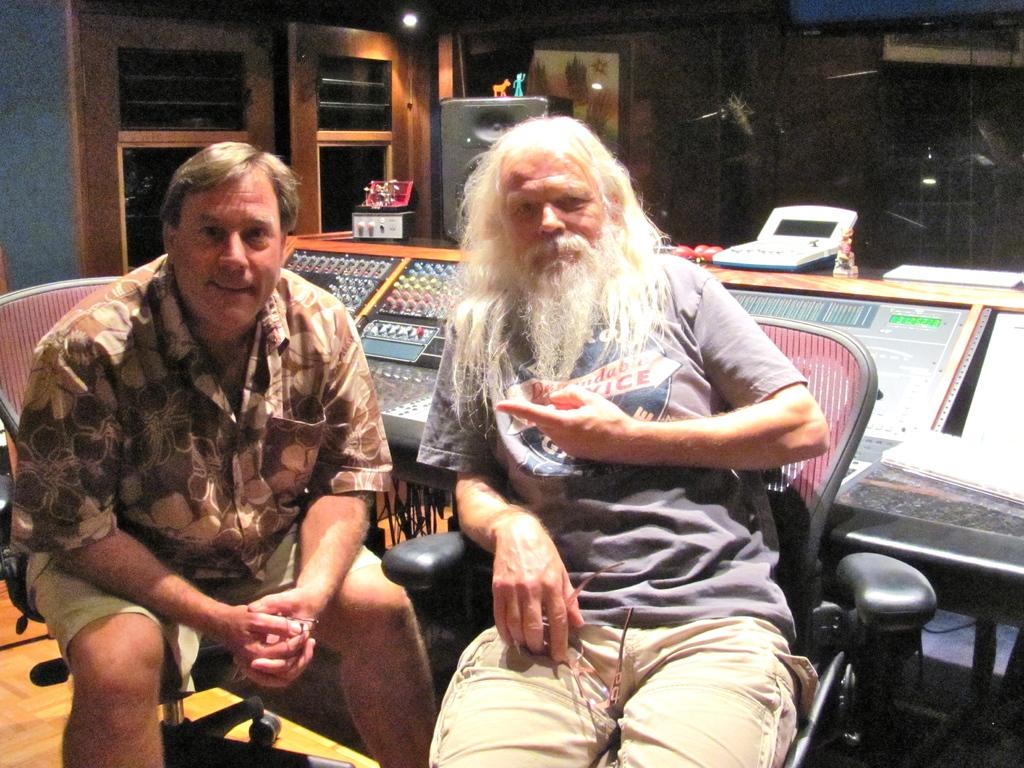How many people are in the image? There are two people in the image. What are the two people doing in the image? The two people are sitting on chairs. What can be seen in the background of the image? There is a door visible in the background of the image. What color is the hydrant in the image? There is no hydrant present in the image. What caused the burst of laughter in the image? There is no laughter or humor depicted in the image; it simply shows two people sitting on chairs. 